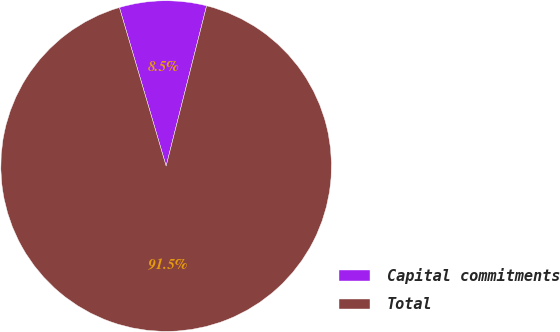Convert chart to OTSL. <chart><loc_0><loc_0><loc_500><loc_500><pie_chart><fcel>Capital commitments<fcel>Total<nl><fcel>8.5%<fcel>91.5%<nl></chart> 